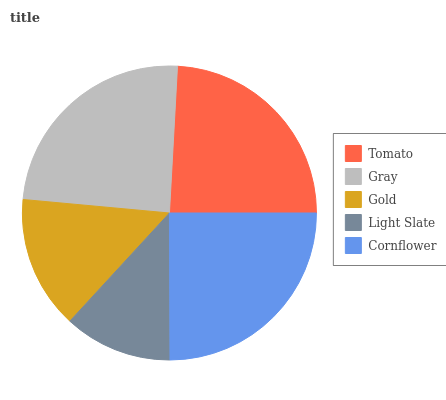Is Light Slate the minimum?
Answer yes or no. Yes. Is Cornflower the maximum?
Answer yes or no. Yes. Is Gray the minimum?
Answer yes or no. No. Is Gray the maximum?
Answer yes or no. No. Is Gray greater than Tomato?
Answer yes or no. Yes. Is Tomato less than Gray?
Answer yes or no. Yes. Is Tomato greater than Gray?
Answer yes or no. No. Is Gray less than Tomato?
Answer yes or no. No. Is Tomato the high median?
Answer yes or no. Yes. Is Tomato the low median?
Answer yes or no. Yes. Is Gold the high median?
Answer yes or no. No. Is Light Slate the low median?
Answer yes or no. No. 